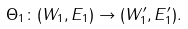<formula> <loc_0><loc_0><loc_500><loc_500>\Theta _ { 1 } \colon ( W _ { 1 } , E _ { 1 } ) \to ( W ^ { \prime } _ { 1 } , E ^ { \prime } _ { 1 } ) .</formula> 